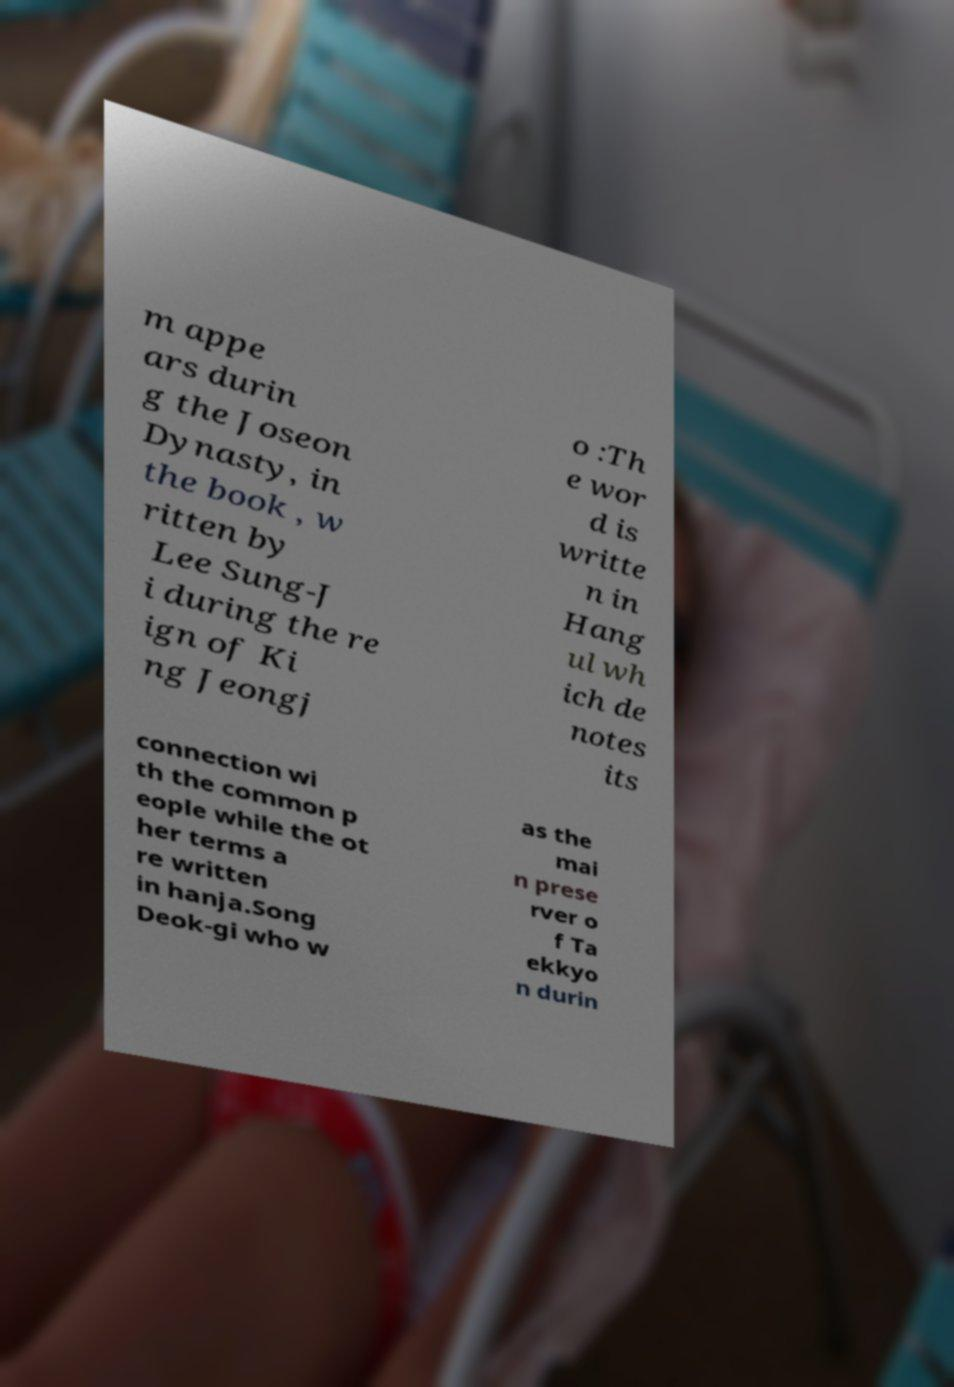Please read and relay the text visible in this image. What does it say? m appe ars durin g the Joseon Dynasty, in the book , w ritten by Lee Sung-J i during the re ign of Ki ng Jeongj o :Th e wor d is writte n in Hang ul wh ich de notes its connection wi th the common p eople while the ot her terms a re written in hanja.Song Deok-gi who w as the mai n prese rver o f Ta ekkyo n durin 